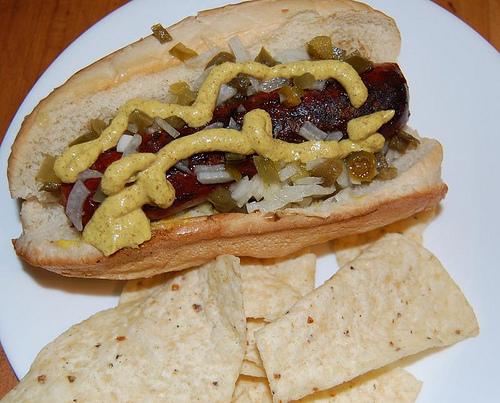What would go well with those chips?
Short answer required. Salsa. What all is on the hot dog?
Be succinct. Onions mustard relish. What kind of chips are on the plate?
Quick response, please. Tortilla. 